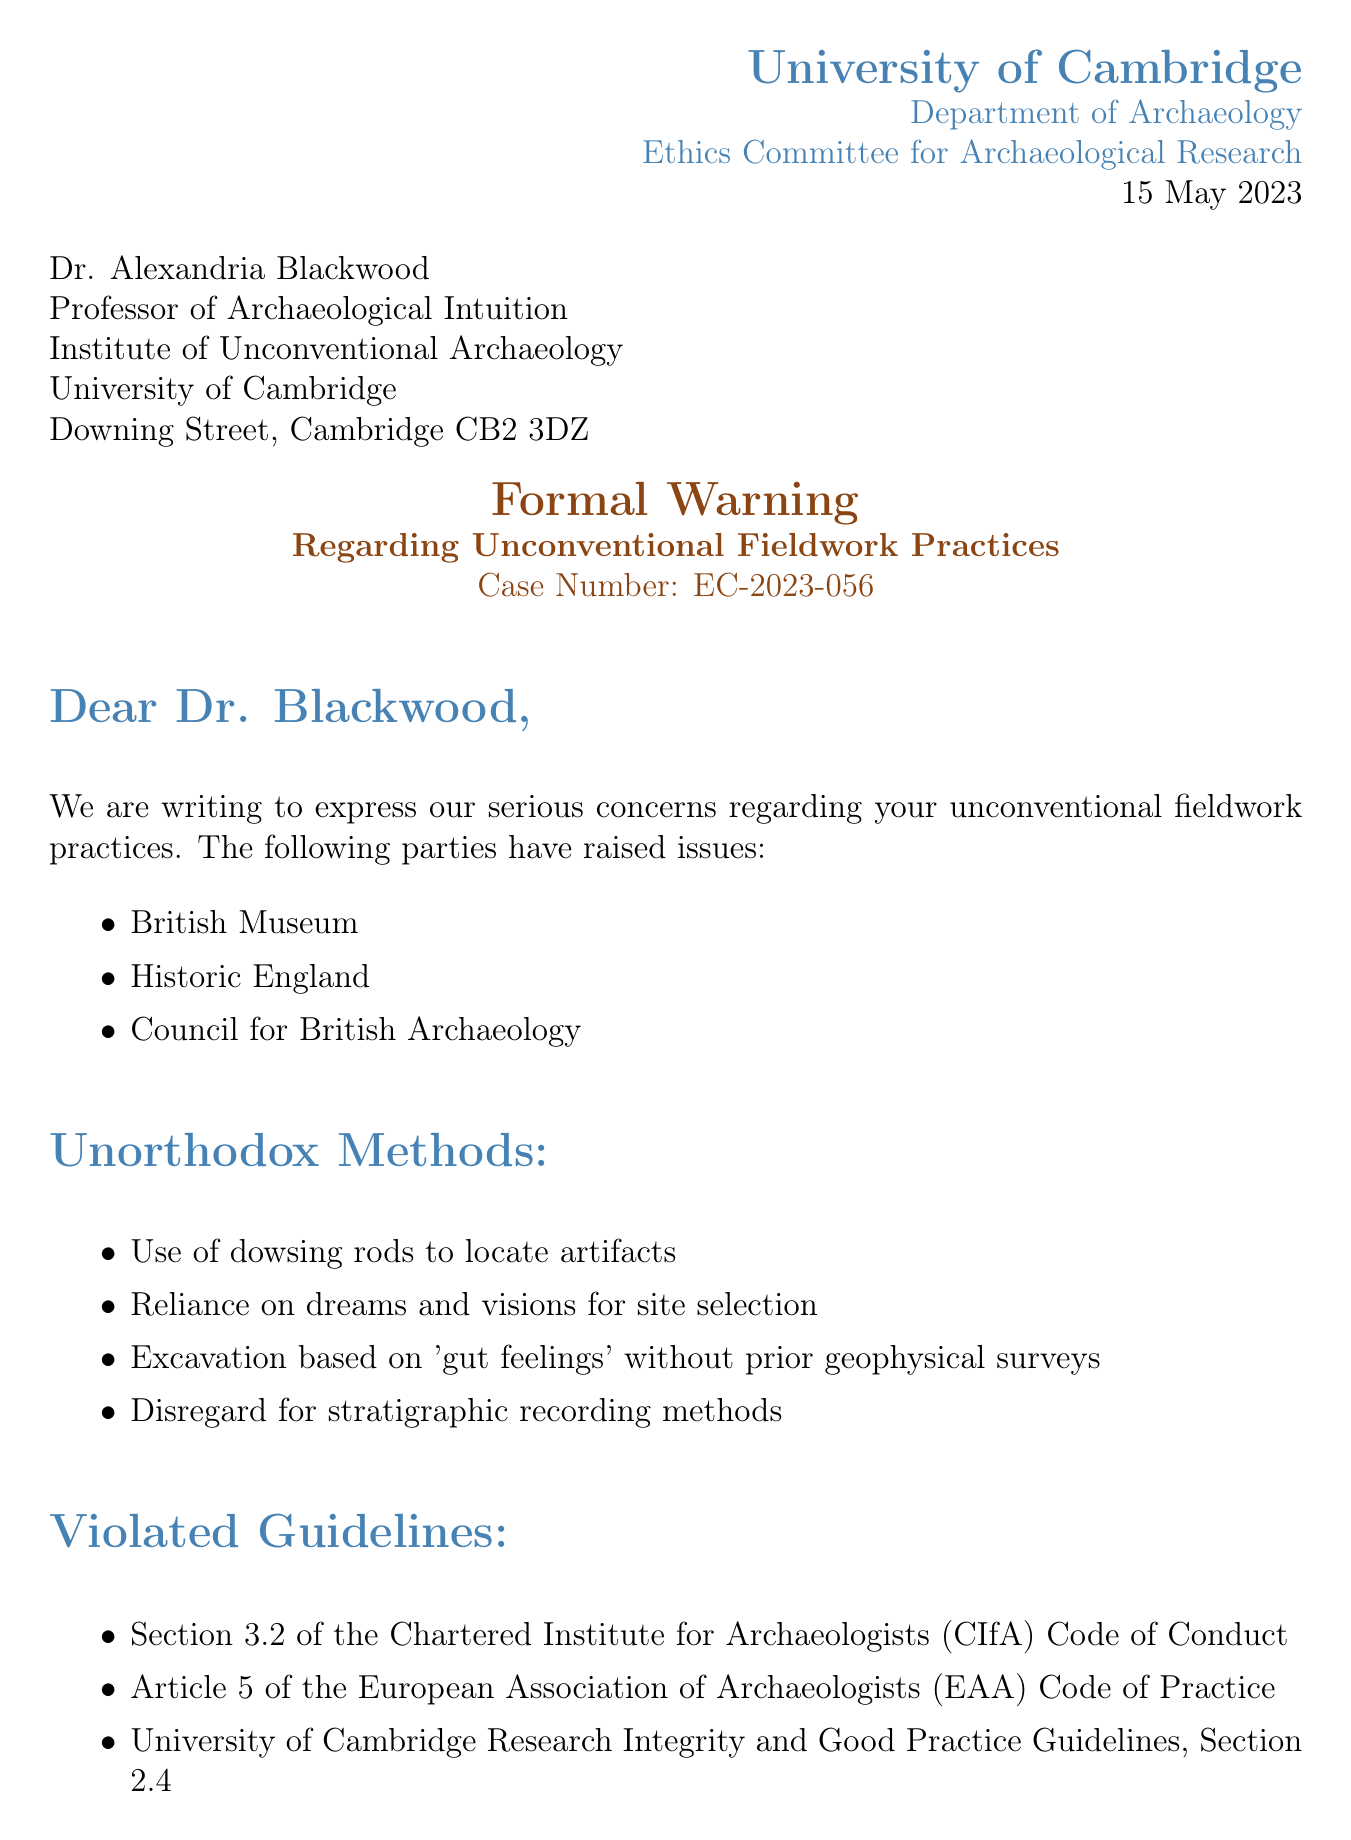What is the university name? The university name is stated at the beginning of the letter.
Answer: University of Cambridge Who is the recipient of the letter? The letter provides the name and title of the recipient at the top.
Answer: Dr. Alexandria Blackwood What date was the letter issued? The date is included in the letter header to indicate when it was written.
Answer: 15 May 2023 What case number is assigned to this formal warning? The case number is mentioned prominently in the subject section of the letter.
Answer: EC-2023-056 Which party raised concerns regarding the practices? The letter lists multiple parties that expressed concerns in a dedicated section.
Answer: British Museum What is one method described as unorthodox? The letter includes a list of methods considered unconventional in archaeological practices.
Answer: Use of dowsing rods to locate artifacts What is one of the potential consequences mentioned? The letter outlines potential repercussions in a specific section.
Answer: Damage to archaeological sites How long does the recipient have to appeal the decision? The appeal deadline is explicitly stated toward the end of the letter.
Answer: 14 days Who is the chair of the Ethics Committee? The letter concludes with the names and roles of committee members.
Answer: Professor Emma Hodgkins What action is required regarding a workshop? The letter specifies a required action involving education on scientific methods.
Answer: Attend a mandatory workshop on scientific archaeological methods 